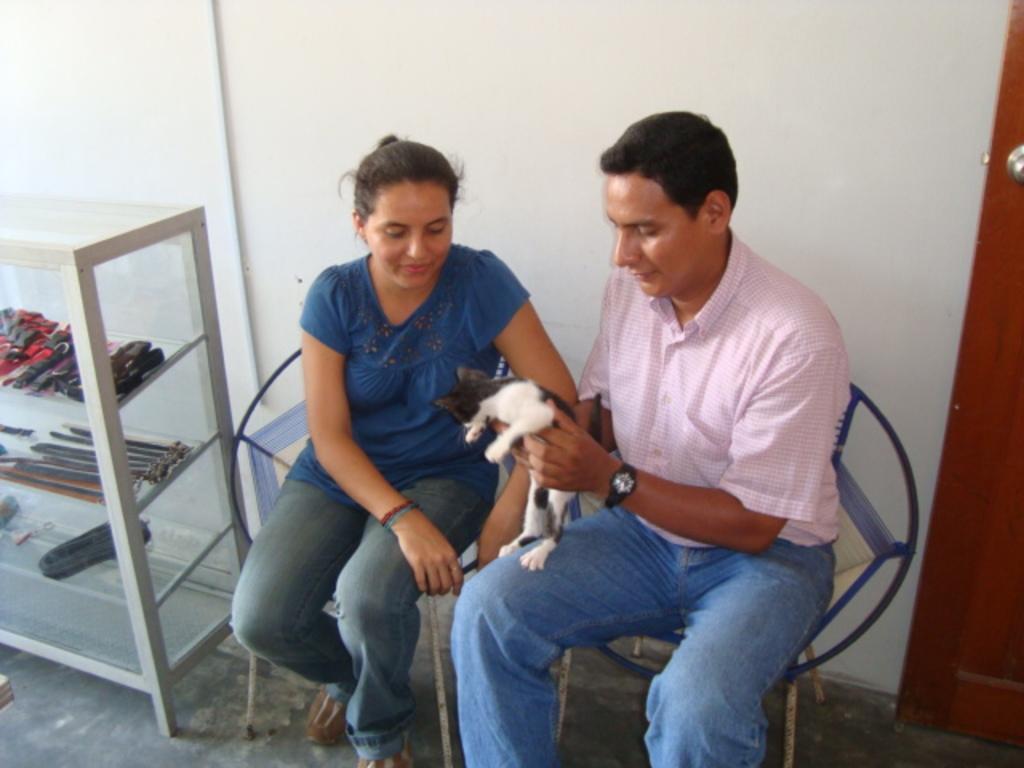In one or two sentences, can you explain what this image depicts? In the background we can see the wall, door and objects are placed in the racks. In this picture we can see a man holding a cat and we can see a woman beside him. They both are sitting on the chairs and they both are staring at a cat. At the bottom portion of the picture we can see the floor. 